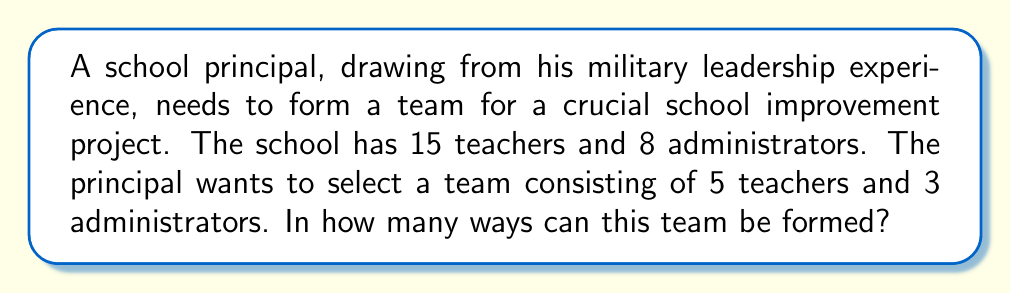Can you answer this question? To solve this problem, we need to use the combination formula. We'll select teachers and administrators separately and then use the multiplication principle to find the total number of ways to form the team.

1. Selecting teachers:
   We need to choose 5 teachers out of 15. This can be done in $\binom{15}{5}$ ways.
   $$\binom{15}{5} = \frac{15!}{5!(15-5)!} = \frac{15!}{5!10!} = 3003$$

2. Selecting administrators:
   We need to choose 3 administrators out of 8. This can be done in $\binom{8}{3}$ ways.
   $$\binom{8}{3} = \frac{8!}{3!(8-3)!} = \frac{8!}{3!5!} = 56$$

3. Using the multiplication principle:
   The total number of ways to form the team is the product of the number of ways to select teachers and the number of ways to select administrators.

   Total number of ways = $\binom{15}{5} \times \binom{8}{3}$
   $$ = 3003 \times 56 = 168,168$$
Answer: The team can be formed in 168,168 different ways. 